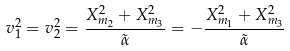<formula> <loc_0><loc_0><loc_500><loc_500>v _ { 1 } ^ { 2 } = v _ { 2 } ^ { 2 } = \frac { X _ { m _ { 2 } } ^ { 2 } + X _ { m _ { 3 } } ^ { 2 } } { \tilde { \alpha } } = - \frac { X _ { m _ { 1 } } ^ { 2 } + X _ { m _ { 3 } } ^ { 2 } } { \tilde { \alpha } }</formula> 